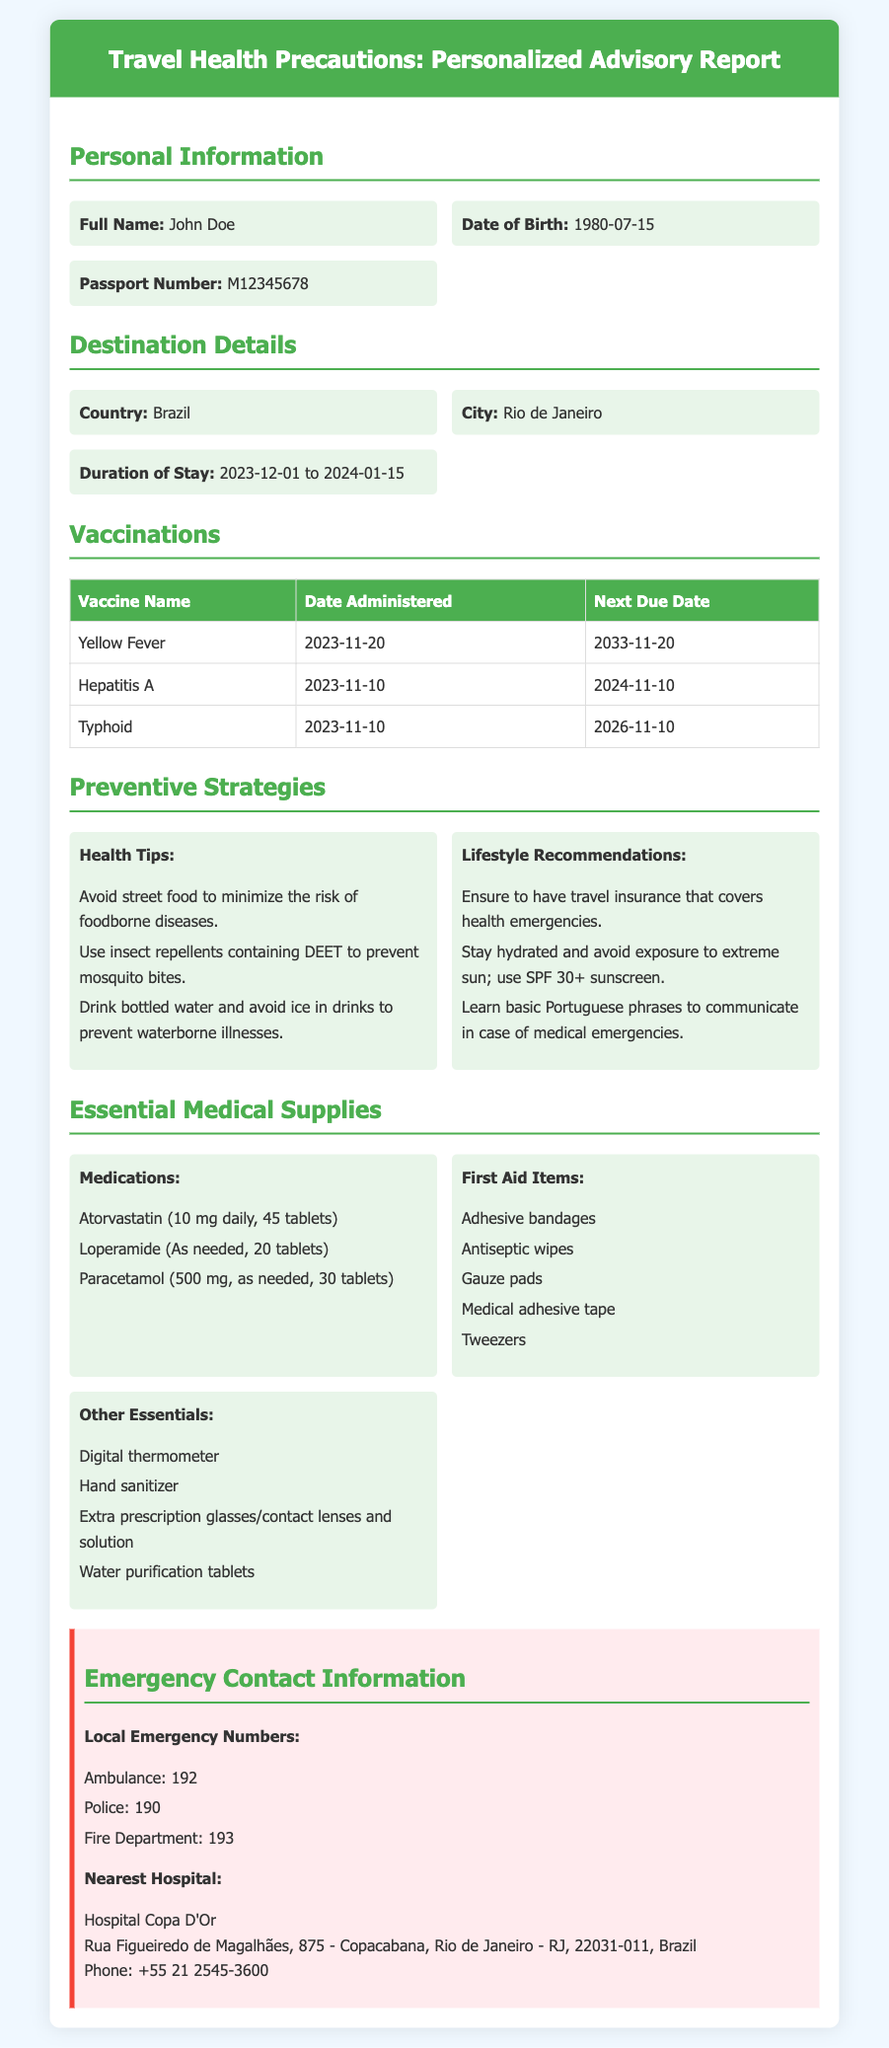What is the full name of the traveler? The traveler's name is listed in the personal information section as John Doe.
Answer: John Doe What is the passport number? The document states the passport number under personal information as M12345678.
Answer: M12345678 What is the duration of stay in Brazil? The document specifies the travel period from December 1, 2023, to January 15, 2024, in the destination details section.
Answer: 2023-12-01 to 2024-01-15 What is the next due date for the Typhoid vaccination? The vaccination table indicates that the next due date for Typhoid is November 10, 2026.
Answer: 2026-11-10 What are the recommended health tips? The preventive strategies section provides health tips, including avoiding street food and using insect repellents.
Answer: Avoid street food to minimize the risk of foodborne diseases How many Atorvastatin tablets are prescribed? The essential medical supplies section lists the number of Atorvastatin tablets as 45.
Answer: 45 tablets Where is the nearest hospital located? The emergency information section provides the address of the nearest hospital as Hospital Copa D'Or in Copacabana, Rio de Janeiro.
Answer: Hospital Copa D'Or What local emergency number should be called for an ambulance? The emergency contact information states that the local emergency number for ambulance services is 192.
Answer: 192 What language should the traveler learn basic phrases in? The lifestyle recommendations suggest that learning basic phrases in Portuguese is advisable for communication.
Answer: Portuguese 